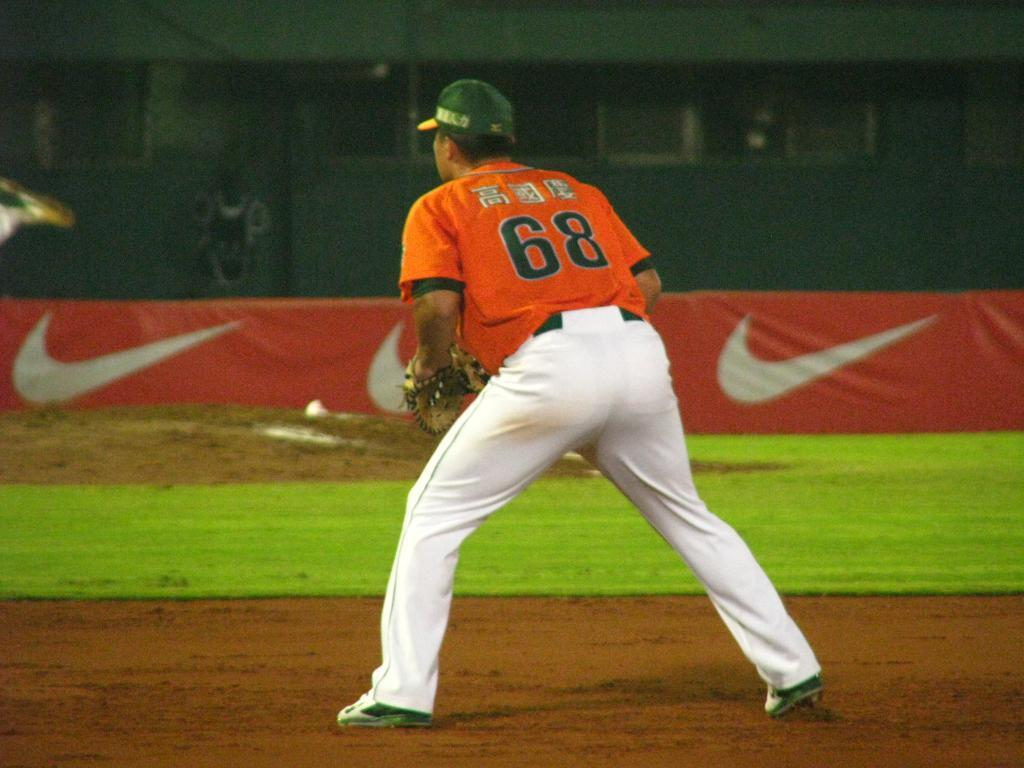<image>
Present a compact description of the photo's key features. Player number 68 is standing out on the field ready to catch the ball. 